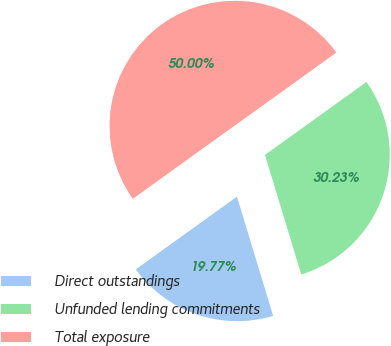Convert chart to OTSL. <chart><loc_0><loc_0><loc_500><loc_500><pie_chart><fcel>Direct outstandings<fcel>Unfunded lending commitments<fcel>Total exposure<nl><fcel>19.77%<fcel>30.23%<fcel>50.0%<nl></chart> 